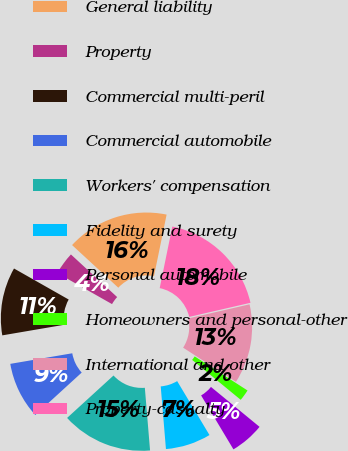<chart> <loc_0><loc_0><loc_500><loc_500><pie_chart><fcel>General liability<fcel>Property<fcel>Commercial multi-peril<fcel>Commercial automobile<fcel>Workers' compensation<fcel>Fidelity and surety<fcel>Personal automobile<fcel>Homeowners and personal-other<fcel>International and other<fcel>Property-casualty<nl><fcel>16.36%<fcel>3.64%<fcel>10.91%<fcel>9.09%<fcel>14.54%<fcel>7.27%<fcel>5.46%<fcel>1.82%<fcel>12.73%<fcel>18.18%<nl></chart> 